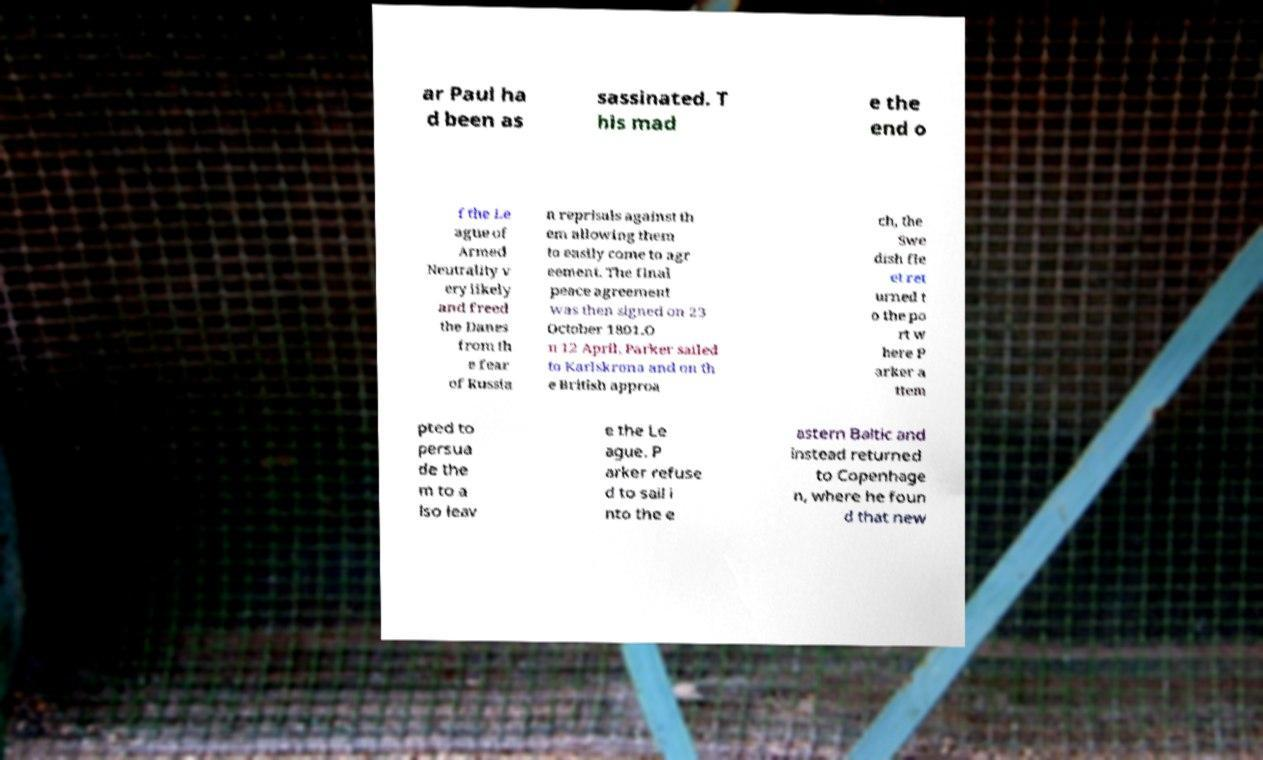There's text embedded in this image that I need extracted. Can you transcribe it verbatim? ar Paul ha d been as sassinated. T his mad e the end o f the Le ague of Armed Neutrality v ery likely and freed the Danes from th e fear of Russia n reprisals against th em allowing them to easily come to agr eement. The final peace agreement was then signed on 23 October 1801.O n 12 April, Parker sailed to Karlskrona and on th e British approa ch, the Swe dish fle et ret urned t o the po rt w here P arker a ttem pted to persua de the m to a lso leav e the Le ague. P arker refuse d to sail i nto the e astern Baltic and instead returned to Copenhage n, where he foun d that new 